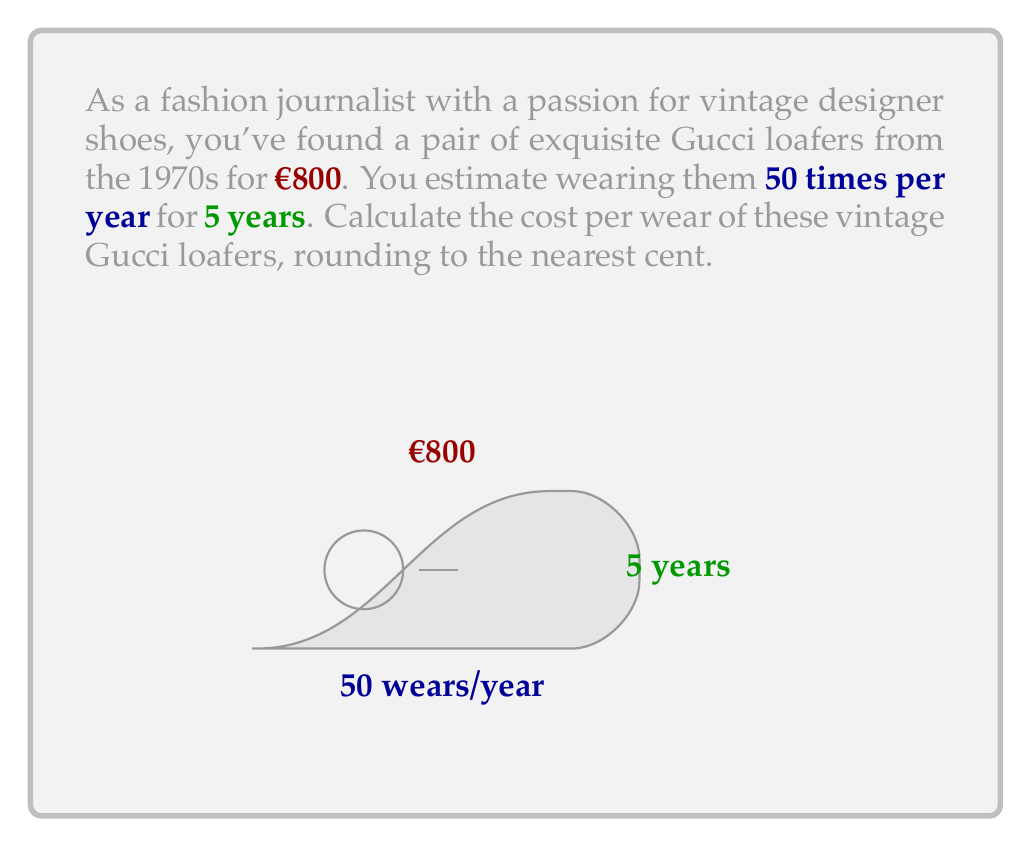Give your solution to this math problem. To calculate the cost per wear, we need to follow these steps:

1) First, determine the total number of times the shoes will be worn:
   $$\text{Total wears} = \text{Wears per year} \times \text{Number of years}$$
   $$\text{Total wears} = 50 \times 5 = 250 \text{ wears}$$

2) Now, we can calculate the cost per wear by dividing the initial cost by the total number of wears:
   $$\text{Cost per wear} = \frac{\text{Initial cost}}{\text{Total wears}}$$
   $$\text{Cost per wear} = \frac{€800}{250} = €3.20$$

3) Rounding to the nearest cent:
   $$\text{Cost per wear} \approx €3.20$$

Therefore, the cost per wear of these vintage Gucci loafers is €3.20.
Answer: €3.20 per wear 